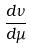<formula> <loc_0><loc_0><loc_500><loc_500>\frac { d \nu } { d \mu }</formula> 